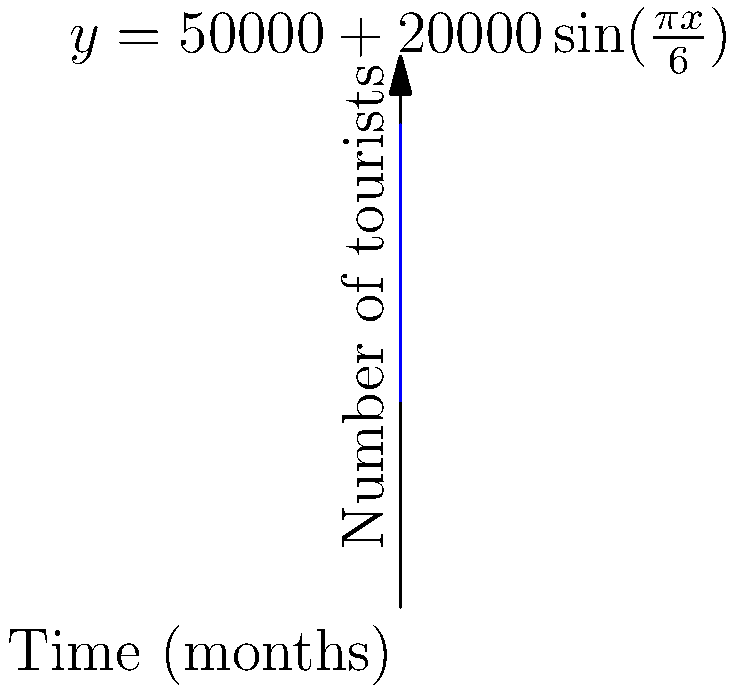The graph shows the number of tourists visiting our city over a 12-month period. The function describing this trend is given by $y = 50000 + 20000\sin(\frac{\pi x}{6})$, where $y$ is the number of tourists and $x$ is the time in months. At what month is the rate of change in tourist numbers the highest, and what is this maximum rate? To find the month with the highest rate of change and its value:

1) The rate of change is given by the derivative of the function:
   $\frac{dy}{dx} = 20000 \cdot \frac{\pi}{6} \cos(\frac{\pi x}{6})$

2) The maximum rate occurs when $\cos(\frac{\pi x}{6})$ is at its maximum, which is 1.

3) This happens when $\frac{\pi x}{6} = 0, 2\pi, 4\pi, ...$

4) Solving for x:
   $x = 0, 12, 24, ...$

5) Within our 12-month period, this occurs at $x = 0$ and $x = 12$, which correspond to the beginning and end of the year.

6) The maximum rate is:
   $\frac{dy}{dx}_{max} = 20000 \cdot \frac{\pi}{6} \cdot 1 = \frac{10000\pi}{3} \approx 10472$ tourists per month

Therefore, the rate of change is highest at the beginning (month 0) and end (month 12) of the year, with a value of approximately 10,472 tourists per month.
Answer: Month 0 or 12; $\frac{10000\pi}{3}$ tourists/month 